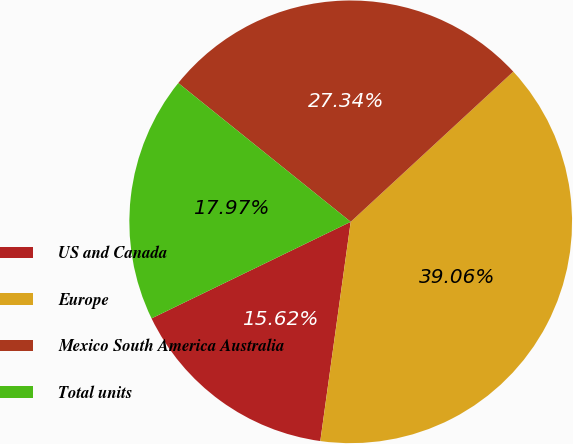Convert chart. <chart><loc_0><loc_0><loc_500><loc_500><pie_chart><fcel>US and Canada<fcel>Europe<fcel>Mexico South America Australia<fcel>Total units<nl><fcel>15.62%<fcel>39.06%<fcel>27.34%<fcel>17.97%<nl></chart> 